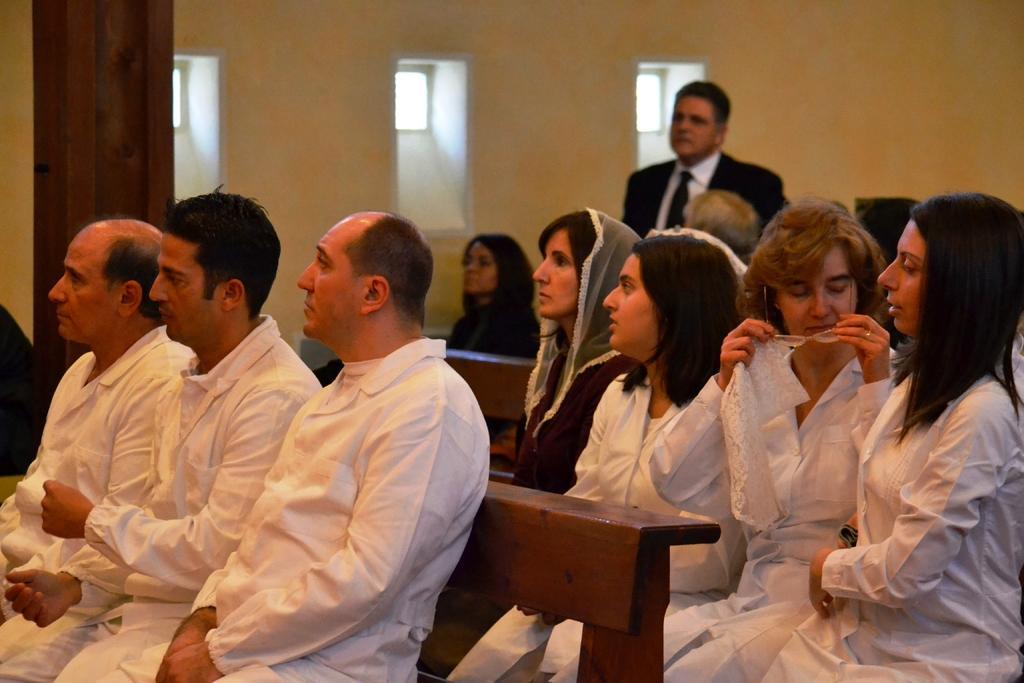Can you describe this image briefly? In the picture I can see few persons sitting on benches and there is a person standing in the background. 